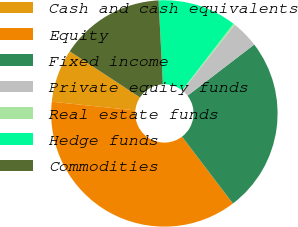<chart> <loc_0><loc_0><loc_500><loc_500><pie_chart><fcel>Cash and cash equivalents<fcel>Equity<fcel>Fixed income<fcel>Private equity funds<fcel>Real estate funds<fcel>Hedge funds<fcel>Commodities<nl><fcel>7.59%<fcel>37.0%<fcel>25.06%<fcel>3.91%<fcel>0.24%<fcel>11.26%<fcel>14.94%<nl></chart> 